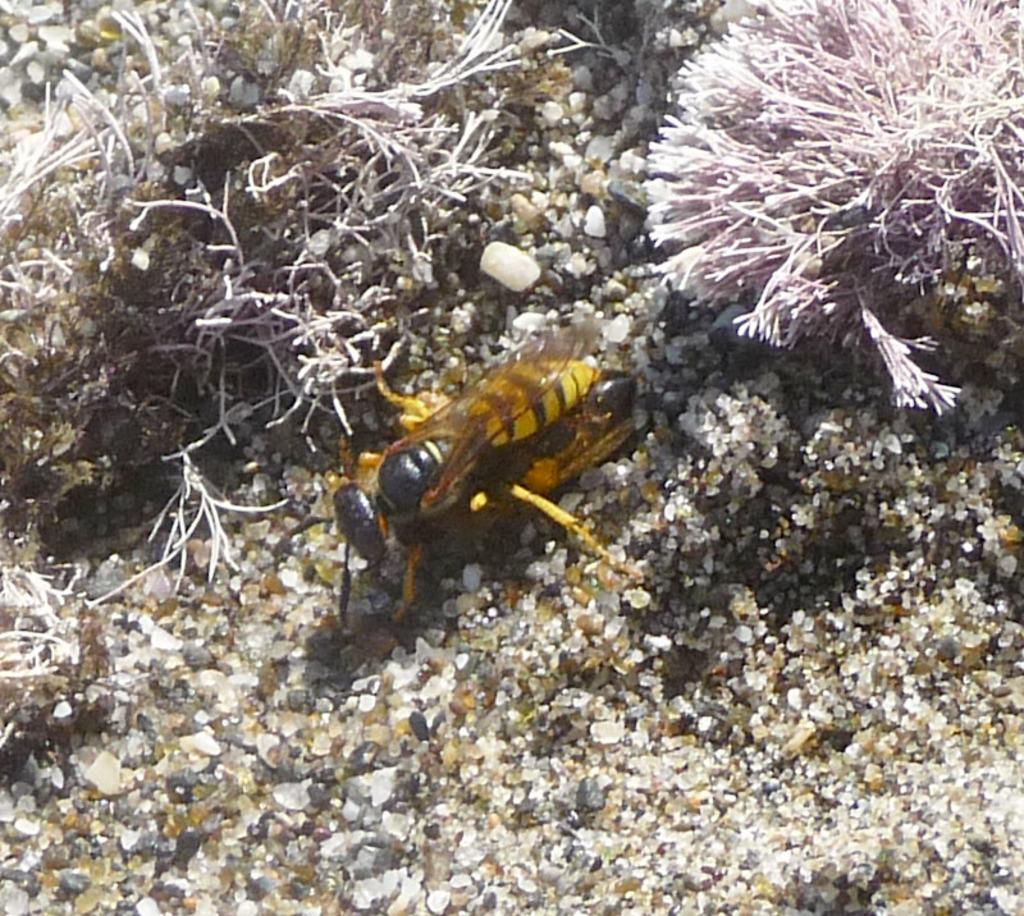What type of insect can be seen on the ground in the image? There is a hornet present on the ground in the image. What type of vegetation is visible in the image? There is grass present in the image. How many geese are flying over the tramp in the image? There is no tramp or geese present in the image. 